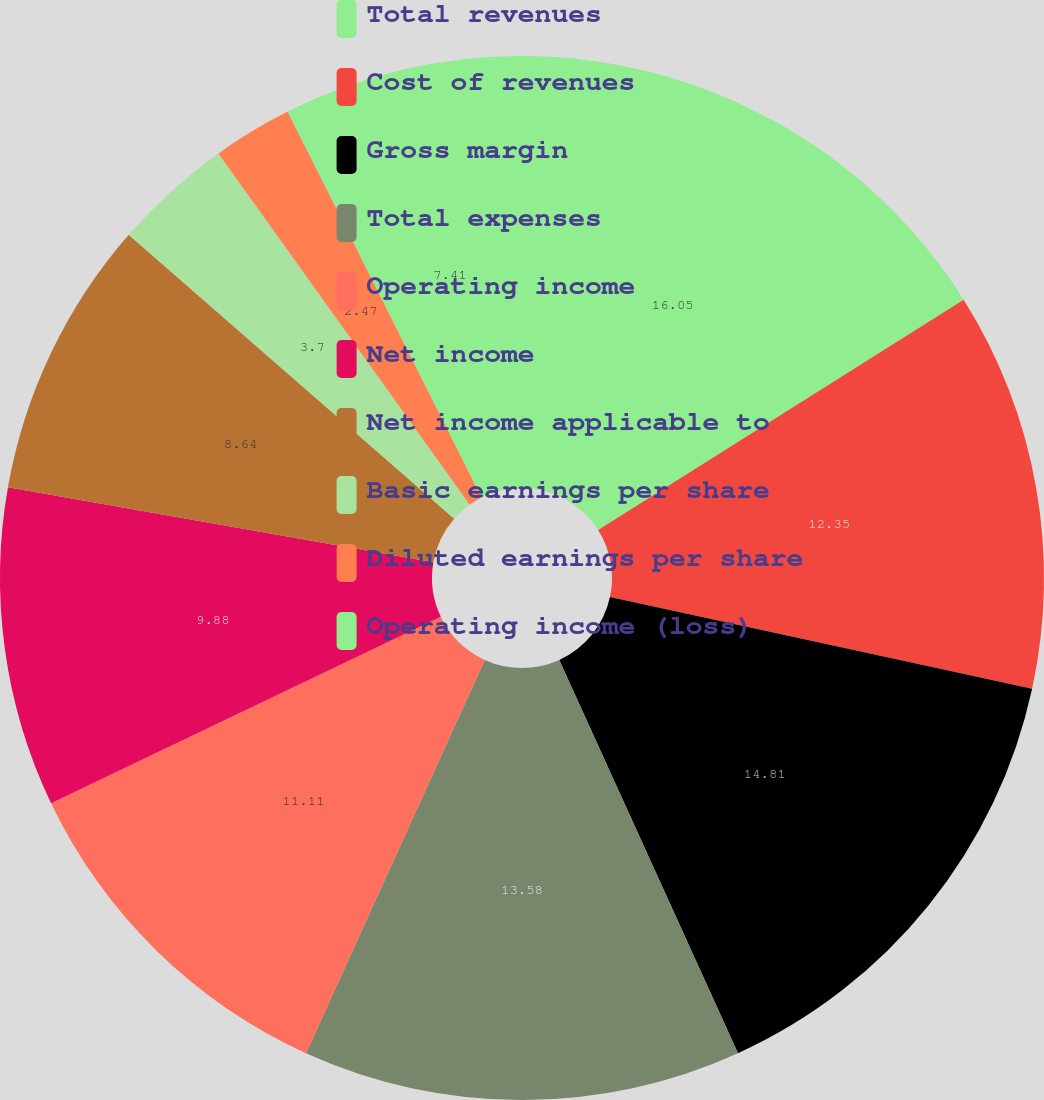<chart> <loc_0><loc_0><loc_500><loc_500><pie_chart><fcel>Total revenues<fcel>Cost of revenues<fcel>Gross margin<fcel>Total expenses<fcel>Operating income<fcel>Net income<fcel>Net income applicable to<fcel>Basic earnings per share<fcel>Diluted earnings per share<fcel>Operating income (loss)<nl><fcel>16.05%<fcel>12.35%<fcel>14.81%<fcel>13.58%<fcel>11.11%<fcel>9.88%<fcel>8.64%<fcel>3.7%<fcel>2.47%<fcel>7.41%<nl></chart> 